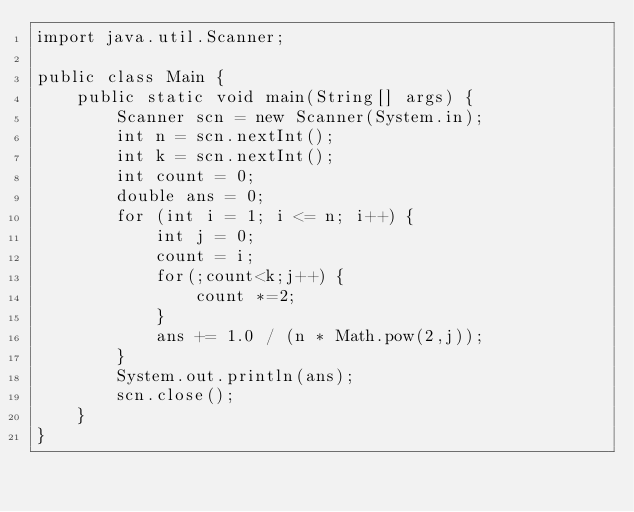<code> <loc_0><loc_0><loc_500><loc_500><_Java_>import java.util.Scanner;

public class Main {
	public static void main(String[] args) {
		Scanner scn = new Scanner(System.in);
		int n = scn.nextInt();
		int k = scn.nextInt();
		int count = 0;
		double ans = 0;
		for (int i = 1; i <= n; i++) {
			int j = 0;
			count = i;
			for(;count<k;j++) {
				count *=2;
			}
			ans += 1.0 / (n * Math.pow(2,j));
		}
		System.out.println(ans);
		scn.close();
	}
}</code> 